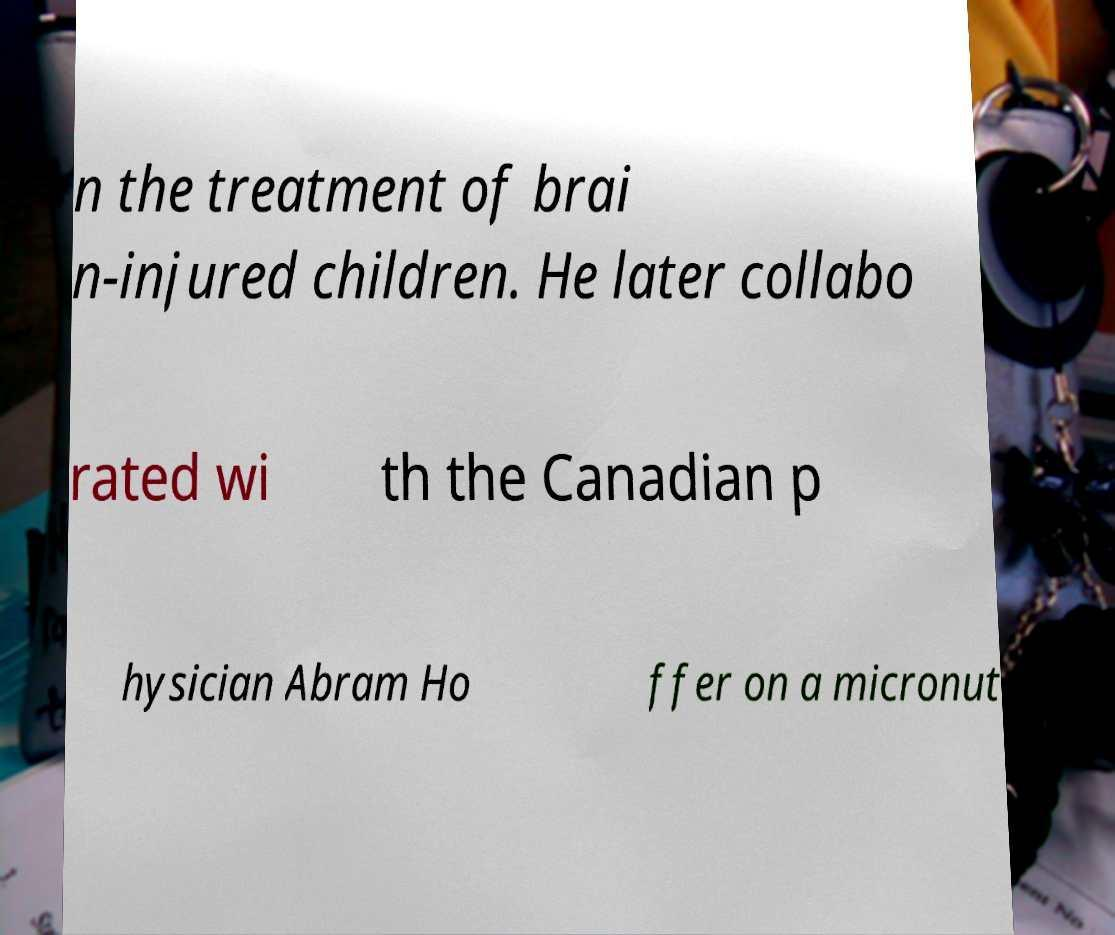What messages or text are displayed in this image? I need them in a readable, typed format. n the treatment of brai n-injured children. He later collabo rated wi th the Canadian p hysician Abram Ho ffer on a micronut 